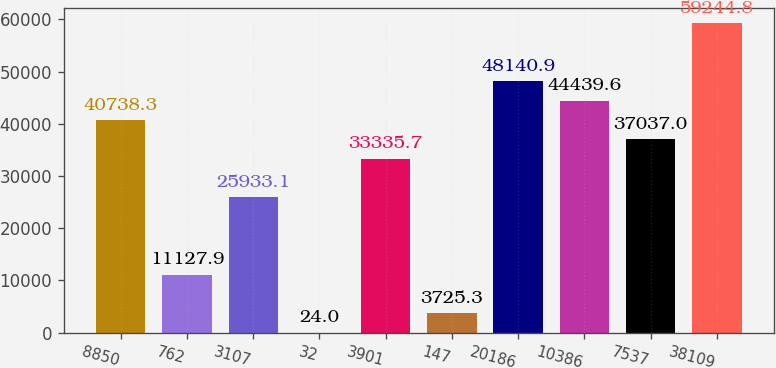<chart> <loc_0><loc_0><loc_500><loc_500><bar_chart><fcel>8850<fcel>762<fcel>3107<fcel>32<fcel>3901<fcel>147<fcel>20186<fcel>10386<fcel>7537<fcel>38109<nl><fcel>40738.3<fcel>11127.9<fcel>25933.1<fcel>24<fcel>33335.7<fcel>3725.3<fcel>48140.9<fcel>44439.6<fcel>37037<fcel>59244.8<nl></chart> 